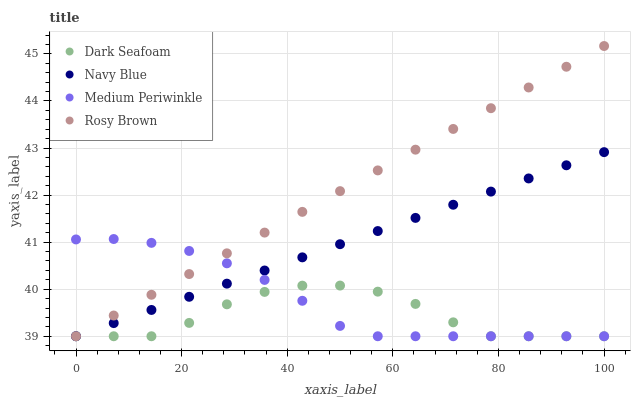Does Dark Seafoam have the minimum area under the curve?
Answer yes or no. Yes. Does Rosy Brown have the maximum area under the curve?
Answer yes or no. Yes. Does Rosy Brown have the minimum area under the curve?
Answer yes or no. No. Does Dark Seafoam have the maximum area under the curve?
Answer yes or no. No. Is Rosy Brown the smoothest?
Answer yes or no. Yes. Is Dark Seafoam the roughest?
Answer yes or no. Yes. Is Dark Seafoam the smoothest?
Answer yes or no. No. Is Rosy Brown the roughest?
Answer yes or no. No. Does Navy Blue have the lowest value?
Answer yes or no. Yes. Does Rosy Brown have the highest value?
Answer yes or no. Yes. Does Dark Seafoam have the highest value?
Answer yes or no. No. Does Medium Periwinkle intersect Rosy Brown?
Answer yes or no. Yes. Is Medium Periwinkle less than Rosy Brown?
Answer yes or no. No. Is Medium Periwinkle greater than Rosy Brown?
Answer yes or no. No. 